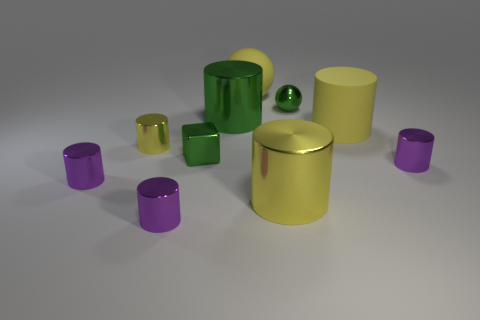Subtract all green cubes. How many purple cylinders are left? 3 Subtract all green cylinders. How many cylinders are left? 6 Subtract all matte cylinders. How many cylinders are left? 6 Subtract all red cylinders. Subtract all green spheres. How many cylinders are left? 7 Subtract all spheres. How many objects are left? 8 Subtract all large metal cylinders. Subtract all purple cylinders. How many objects are left? 5 Add 5 big yellow matte things. How many big yellow matte things are left? 7 Add 6 big matte cylinders. How many big matte cylinders exist? 7 Subtract 0 gray cubes. How many objects are left? 10 